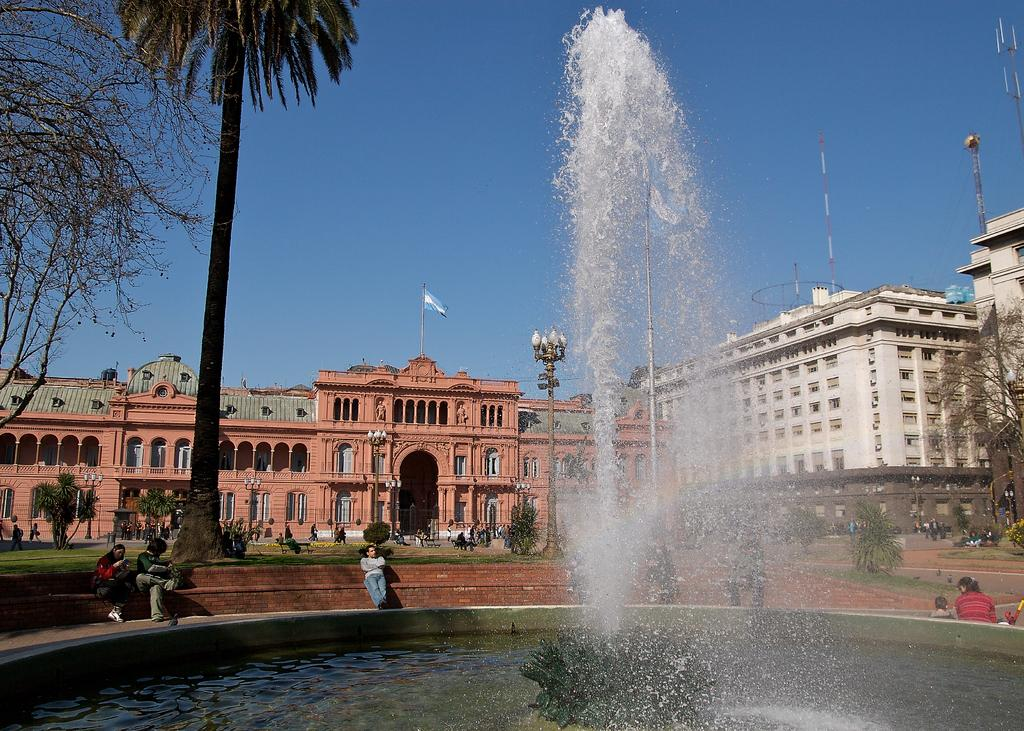What is the main subject in the middle of the image? There is a water fountain in the middle of the image. Where are the people located in the image? The people are sitting on the left side of the image. What type of vegetation can be seen in the image? There are trees in the image. What structures are visible in the background of the image? There are buildings visible at the back side of the image. What is visible at the top of the image? The sky is visible at the top of the image. What is the purpose of the grape in the image? There is no grape present in the image, so it is not possible to determine its purpose. 